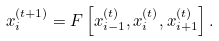<formula> <loc_0><loc_0><loc_500><loc_500>x _ { i } ^ { ( t + 1 ) } = F \left [ x _ { i - 1 } ^ { ( t ) } , x _ { i } ^ { ( t ) } , x _ { i + 1 } ^ { ( t ) } \right ] .</formula> 